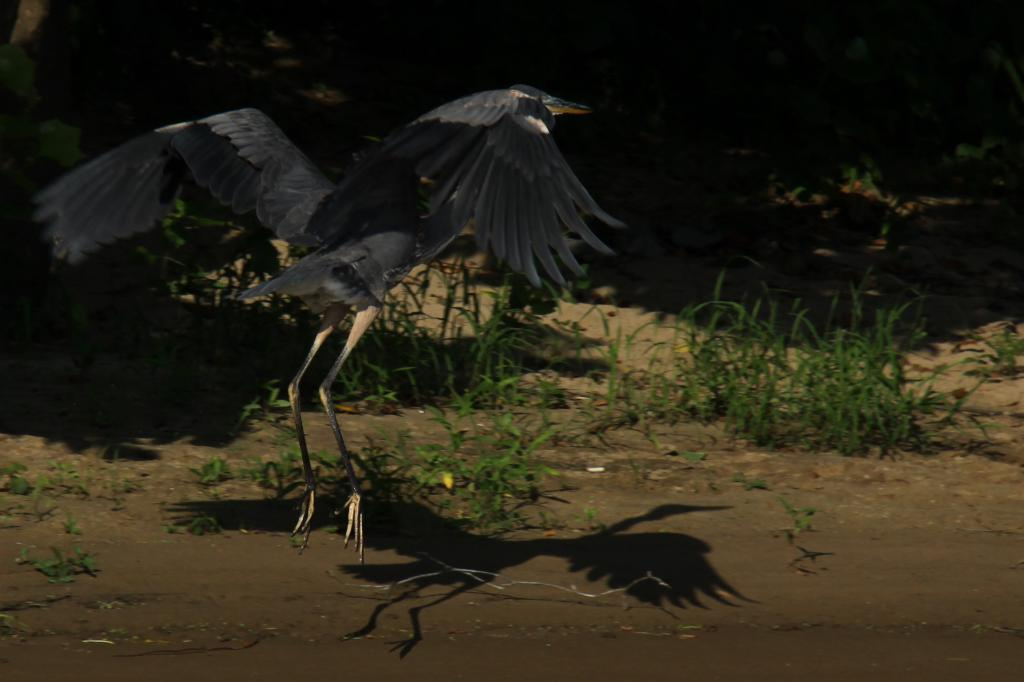What is the bird doing in the image? The bird is flying in the air. What type of vegetation can be seen in the image? There are plants and grass visible in the image. What type of property is being sold in the image? There is no property being sold in the image; it features a bird flying in the air and plants and grass. What game is being played in the image? There is no game being played in the image; it features a bird flying in the air and plants and grass. 